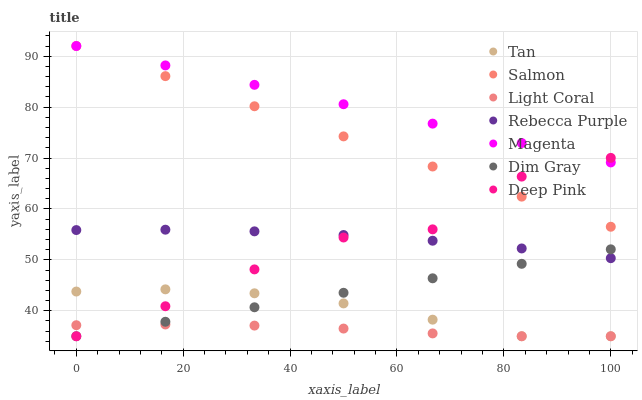Does Light Coral have the minimum area under the curve?
Answer yes or no. Yes. Does Magenta have the maximum area under the curve?
Answer yes or no. Yes. Does Salmon have the minimum area under the curve?
Answer yes or no. No. Does Salmon have the maximum area under the curve?
Answer yes or no. No. Is Magenta the smoothest?
Answer yes or no. Yes. Is Deep Pink the roughest?
Answer yes or no. Yes. Is Salmon the smoothest?
Answer yes or no. No. Is Salmon the roughest?
Answer yes or no. No. Does Dim Gray have the lowest value?
Answer yes or no. Yes. Does Salmon have the lowest value?
Answer yes or no. No. Does Magenta have the highest value?
Answer yes or no. Yes. Does Light Coral have the highest value?
Answer yes or no. No. Is Light Coral less than Rebecca Purple?
Answer yes or no. Yes. Is Salmon greater than Light Coral?
Answer yes or no. Yes. Does Tan intersect Deep Pink?
Answer yes or no. Yes. Is Tan less than Deep Pink?
Answer yes or no. No. Is Tan greater than Deep Pink?
Answer yes or no. No. Does Light Coral intersect Rebecca Purple?
Answer yes or no. No. 